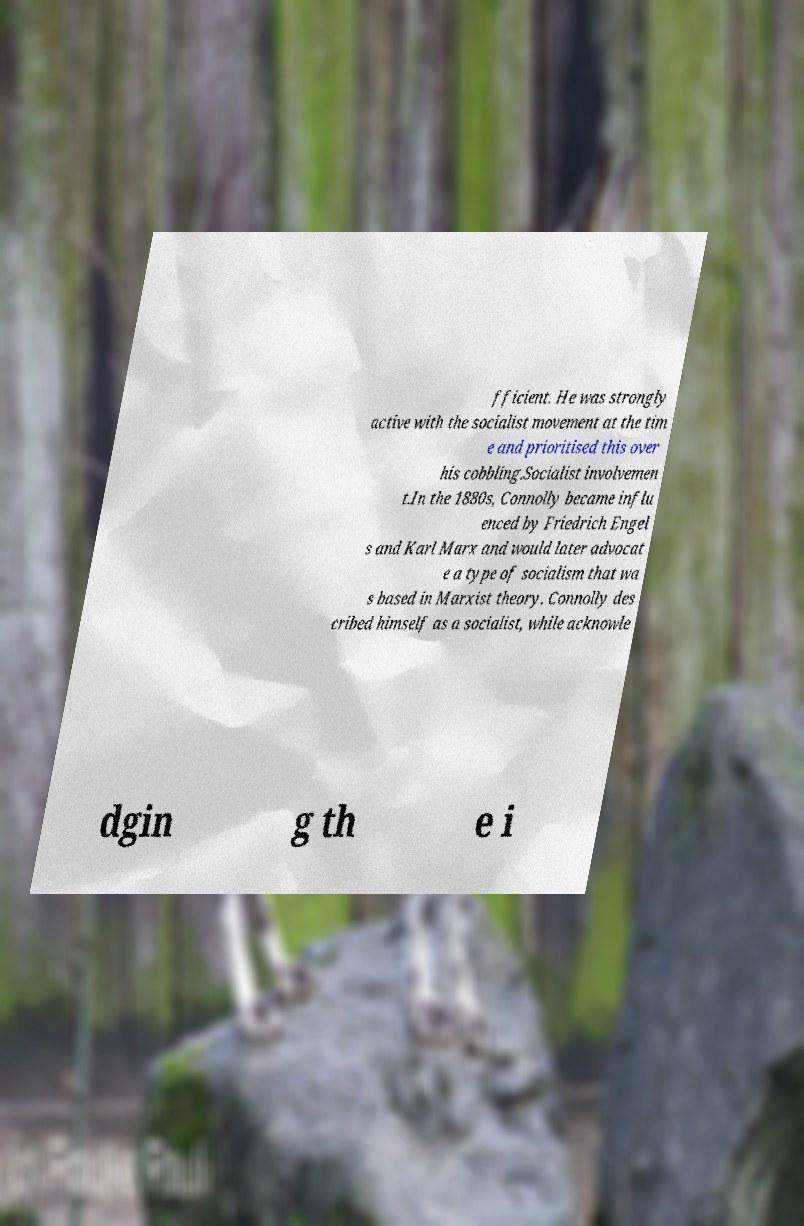Can you read and provide the text displayed in the image?This photo seems to have some interesting text. Can you extract and type it out for me? fficient. He was strongly active with the socialist movement at the tim e and prioritised this over his cobbling.Socialist involvemen t.In the 1880s, Connolly became influ enced by Friedrich Engel s and Karl Marx and would later advocat e a type of socialism that wa s based in Marxist theory. Connolly des cribed himself as a socialist, while acknowle dgin g th e i 